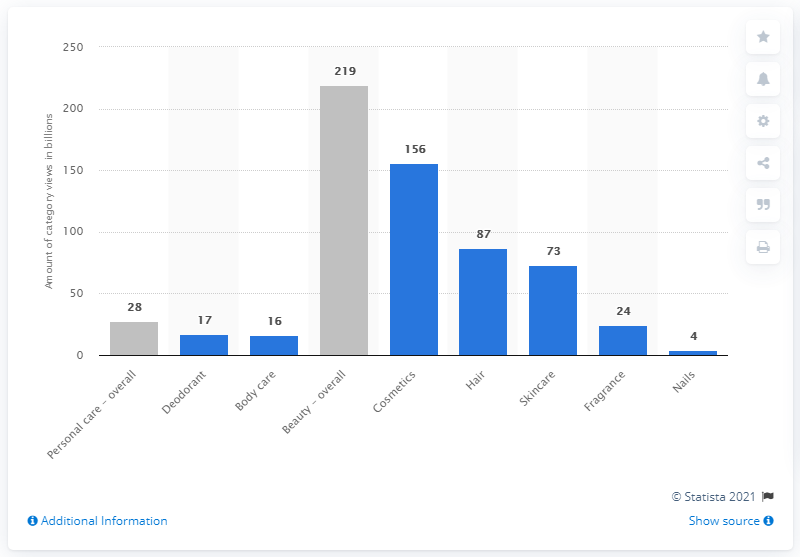List a handful of essential elements in this visual. As of July 2017, the amount of views that cosmetics content had on YouTube was 156. In July 2017, the hair content on YouTube generated 87 video views. 